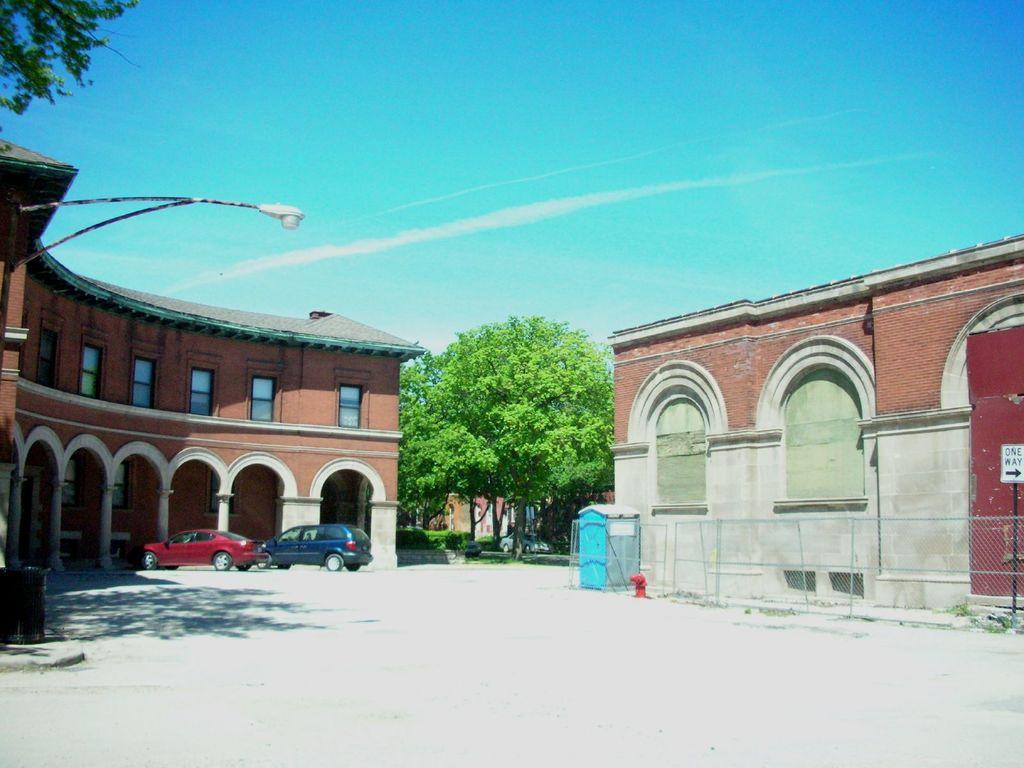What structure is located in the left corner of the image? There is a building in the left corner of the image. What is in front of the building in the image? There are two cars in front of the building. What is located in the right corner of the image? There is another building in the right corner of the image. What type of natural elements can be seen in the background of the image? Trees are present in the background of the image. What type of plastic is covering the windows of the building on the right? There is no plastic covering the windows of the building on the right, as the image does not mention any windows or plastic. 